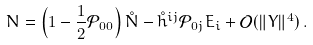Convert formula to latex. <formula><loc_0><loc_0><loc_500><loc_500>N = \left ( 1 - \frac { 1 } { 2 } \mathcal { P } _ { 0 0 } \right ) \mathring { N } - \mathring { h } ^ { i j } \mathcal { P } _ { 0 j } E _ { i } + \mathcal { O } ( \| Y \| ^ { 4 } ) \, .</formula> 